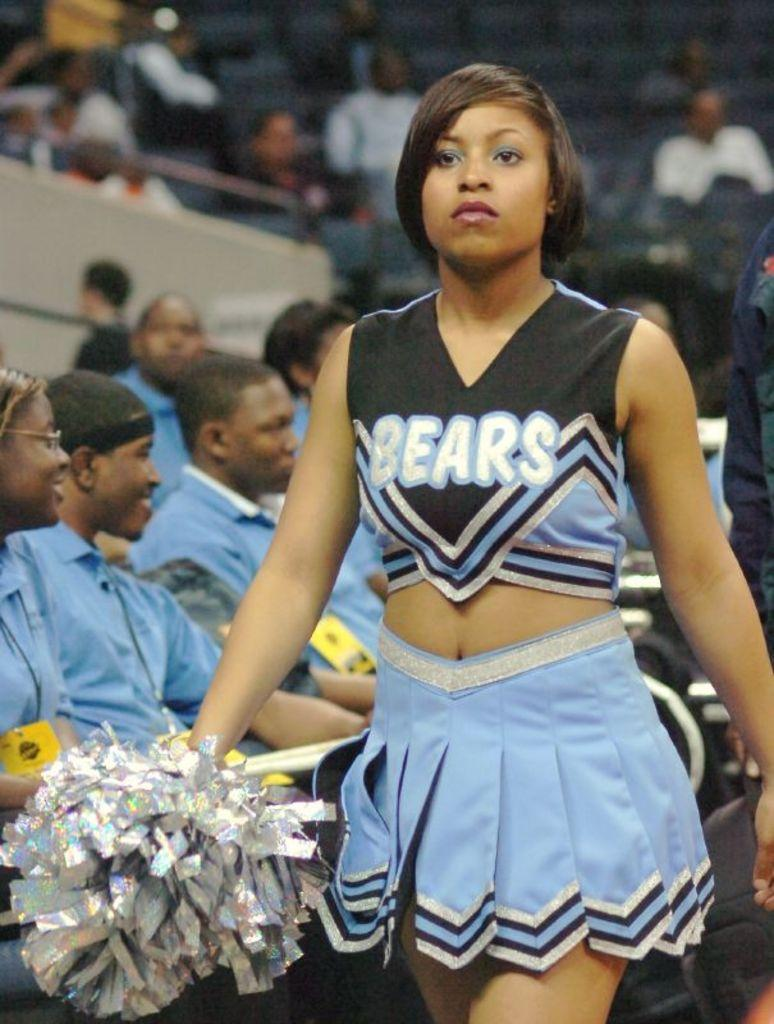Provide a one-sentence caption for the provided image. The Bears cheerleader in a baby blue skirt does not look happy. 